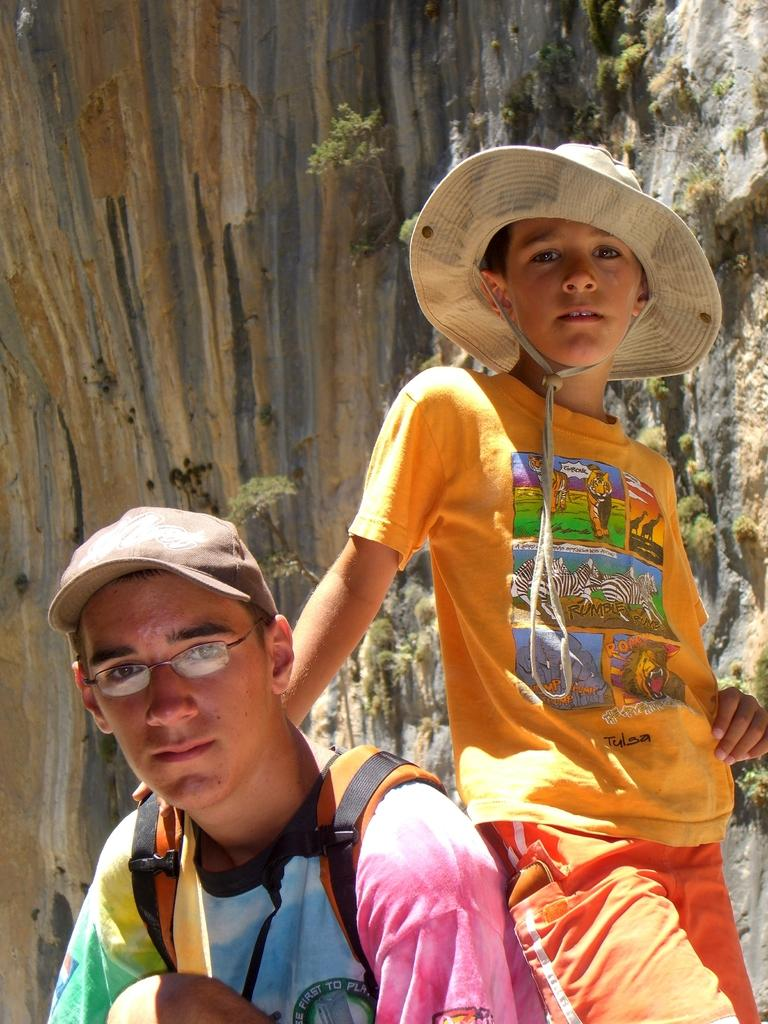How many people are in the image? There are people in the image. What are the people wearing on their heads? The people are wearing caps. Can you describe any specific accessories worn by the people? One person is wearing glasses. What is one person carrying in the image? One person is carrying a bag. What can be seen in the background of the image? There is a rock and a tree trunk in the background of the image. What type of goldfish can be seen swimming near the tree trunk in the image? There are no goldfish present in the image; it features people wearing caps and accessories, as well as a rock and tree trunk in the background. 